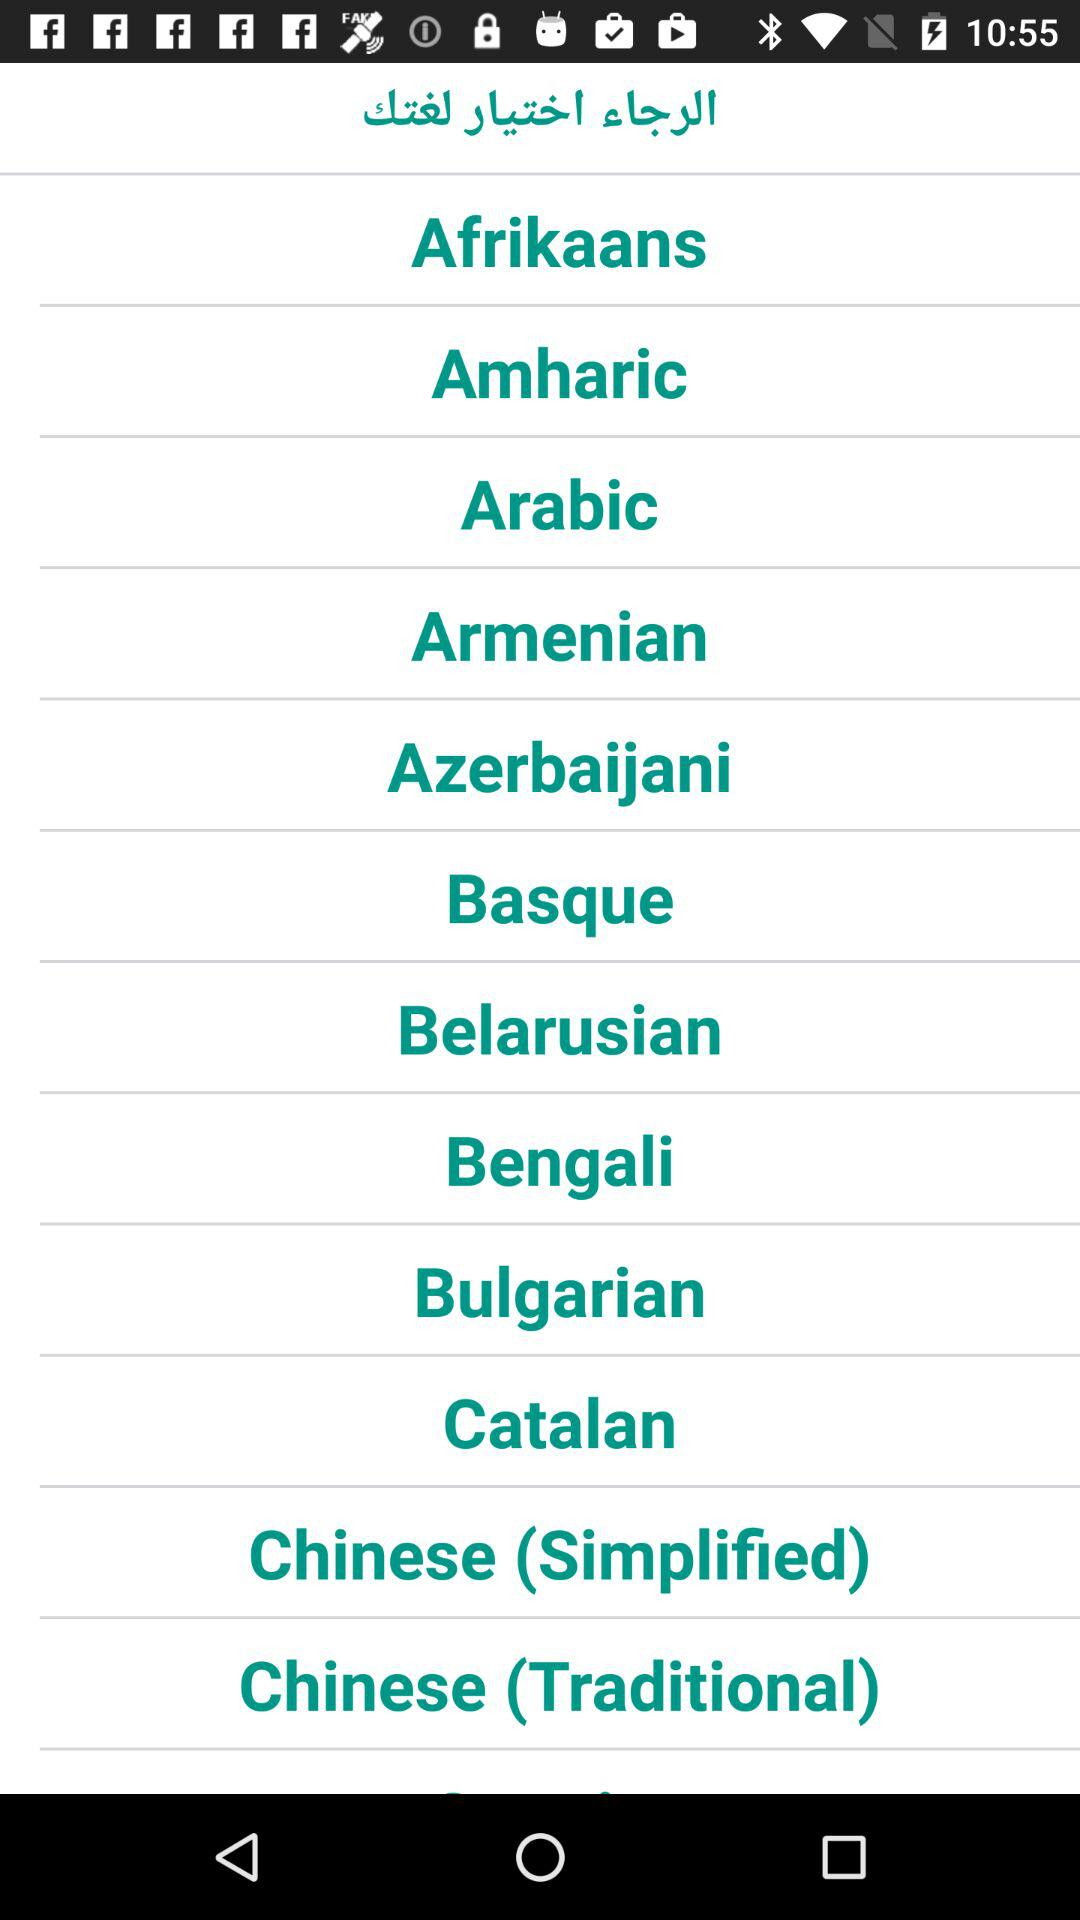What is an available list of the language?
When the provided information is insufficient, respond with <no answer>. <no answer> 